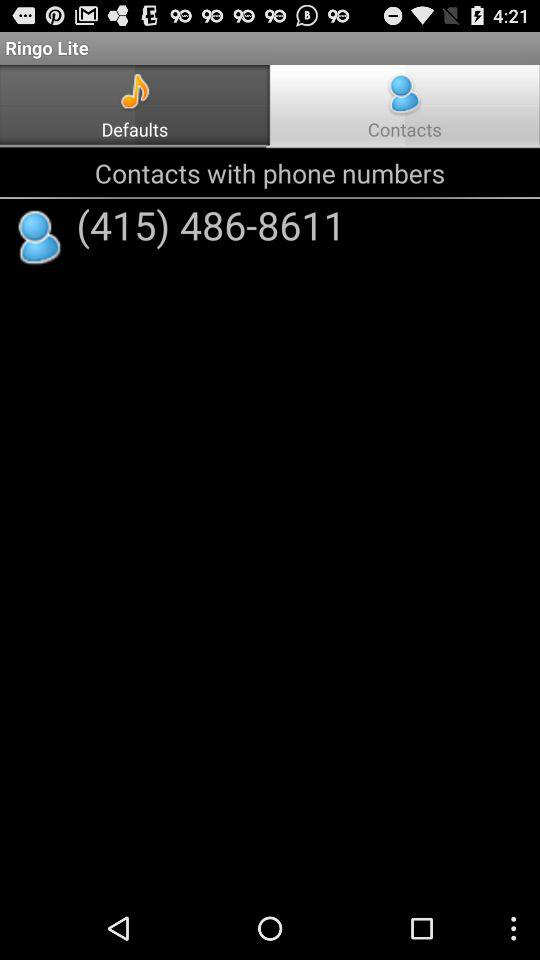What is the selected tab? The selected tab is "Contacts". 